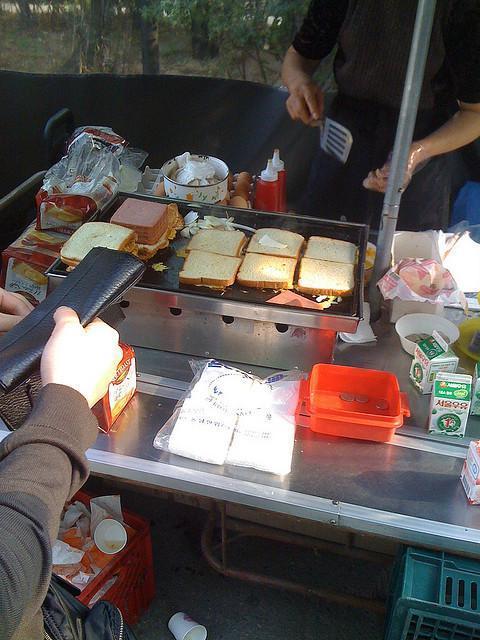How many people are there?
Give a very brief answer. 2. 